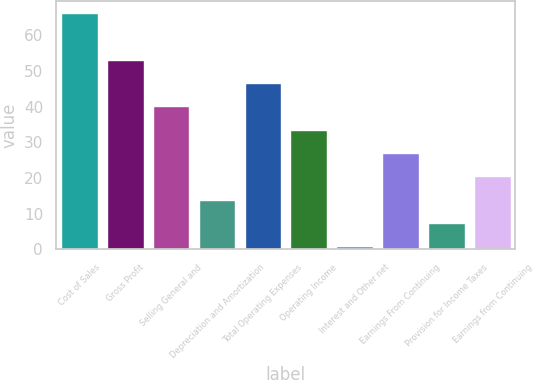<chart> <loc_0><loc_0><loc_500><loc_500><bar_chart><fcel>Cost of Sales<fcel>Gross Profit<fcel>Selling General and<fcel>Depreciation and Amortization<fcel>Total Operating Expenses<fcel>Operating Income<fcel>Interest and Other net<fcel>Earnings From Continuing<fcel>Provision for Income Taxes<fcel>Earnings from Continuing<nl><fcel>66.3<fcel>53.22<fcel>40.14<fcel>13.98<fcel>46.68<fcel>33.6<fcel>0.9<fcel>27.06<fcel>7.44<fcel>20.52<nl></chart> 